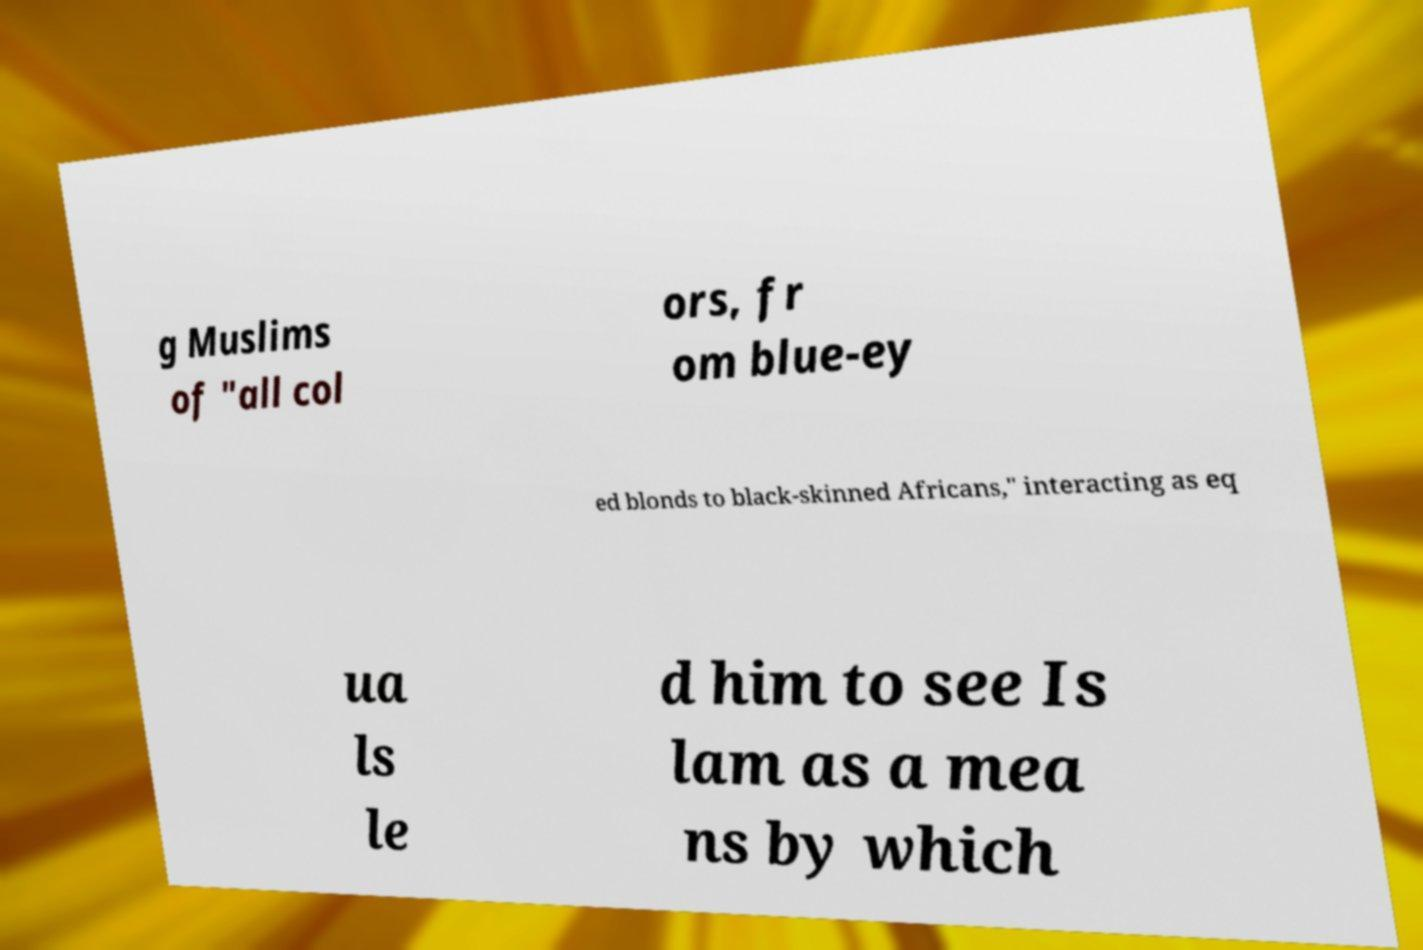What messages or text are displayed in this image? I need them in a readable, typed format. g Muslims of "all col ors, fr om blue-ey ed blonds to black-skinned Africans," interacting as eq ua ls le d him to see Is lam as a mea ns by which 